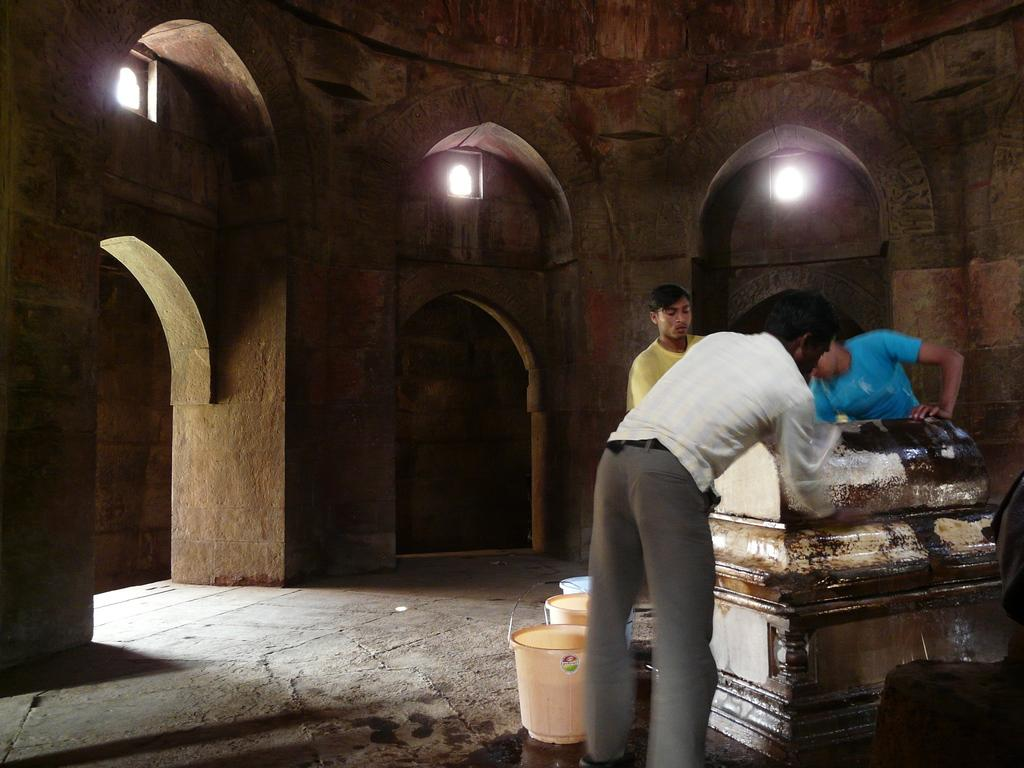How many people are in the image? There are three persons standing on the right side of the image. What are the persons doing in the image? The persons are cleaning a stand. What objects are near the persons? There are three buckets near the persons. What can be seen in the background of the image? There are arches, lights, and a wall visible in the background of the image. What type of body is visible in the image? There is no body present in the image; it features three persons cleaning a stand. Can you see a swing in the image? There is no swing present in the image. 